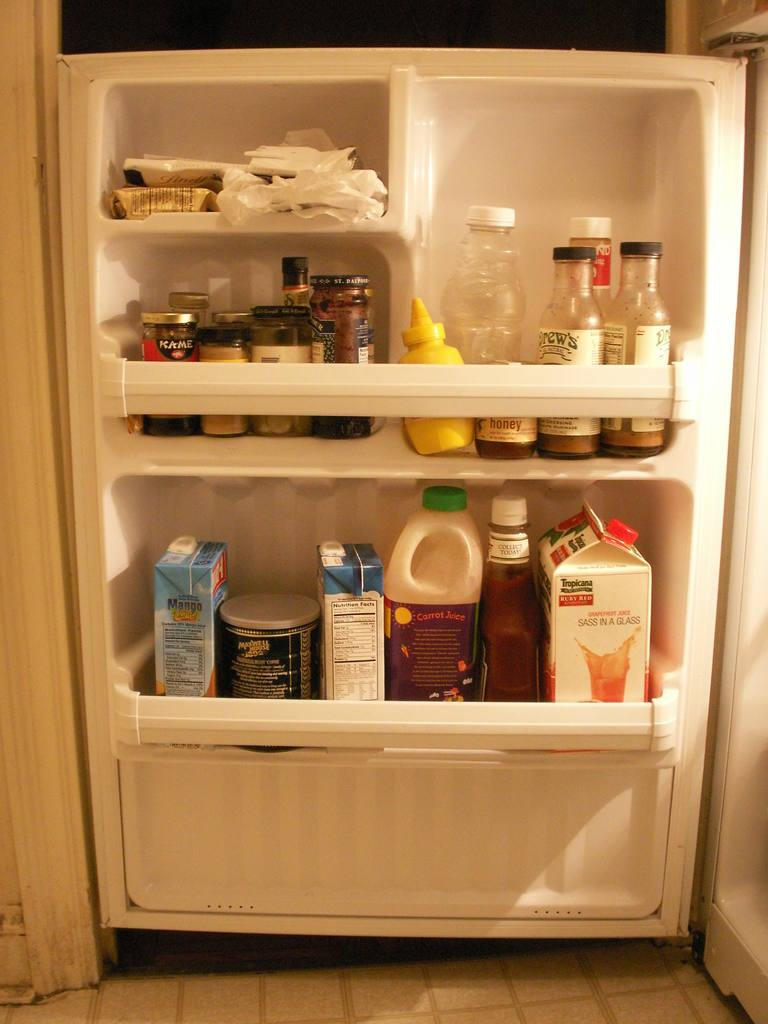Provide a one-sentence caption for the provided image. One of the many items in the refrigerator door is a carton of Tropicana grapefruit juice. 